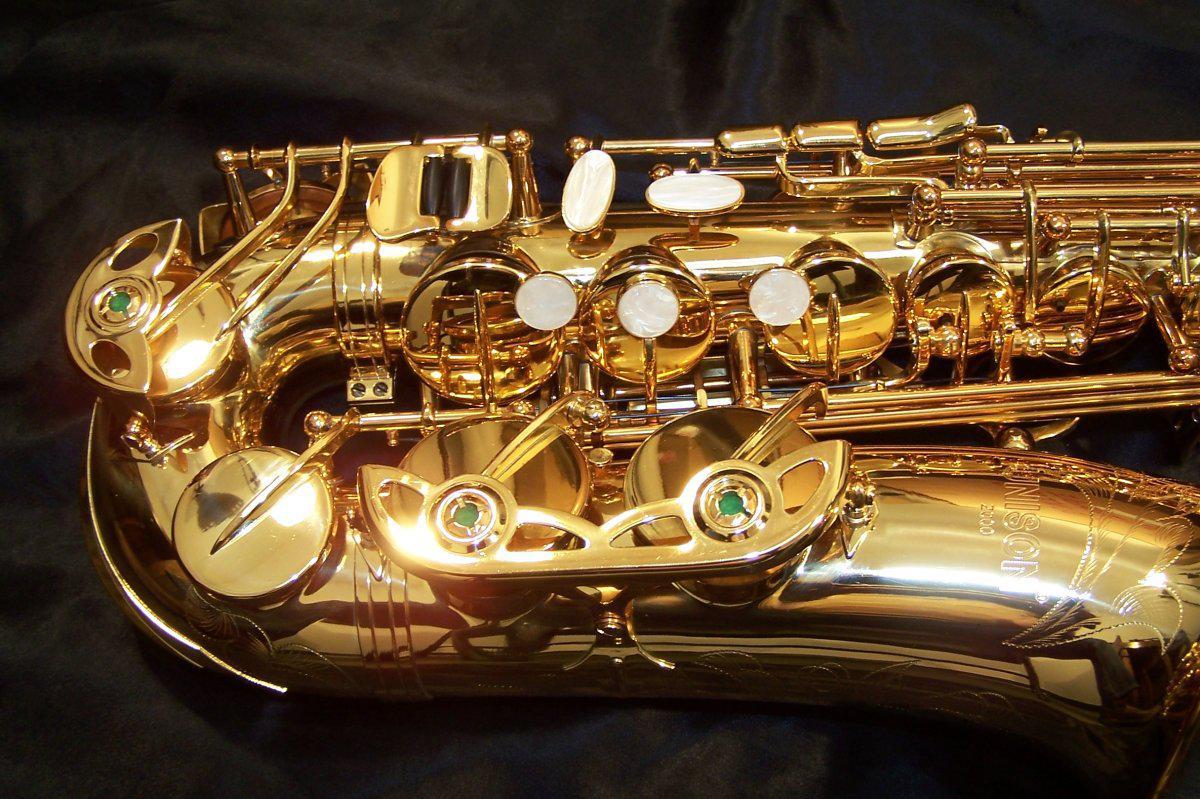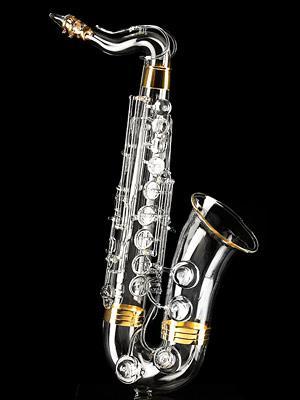The first image is the image on the left, the second image is the image on the right. Assess this claim about the two images: "Each image shows a single saxophone displayed so it is nearly vertical.". Correct or not? Answer yes or no. No. The first image is the image on the left, the second image is the image on the right. Assess this claim about the two images: "Both saxophones are positioned upright.". Correct or not? Answer yes or no. No. 